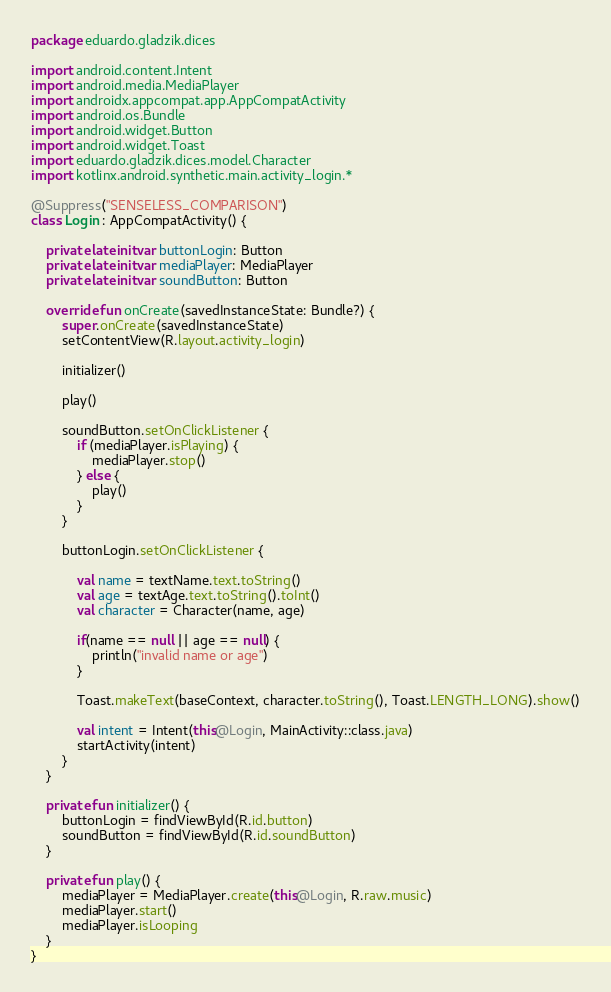Convert code to text. <code><loc_0><loc_0><loc_500><loc_500><_Kotlin_>package eduardo.gladzik.dices

import android.content.Intent
import android.media.MediaPlayer
import androidx.appcompat.app.AppCompatActivity
import android.os.Bundle
import android.widget.Button
import android.widget.Toast
import eduardo.gladzik.dices.model.Character
import kotlinx.android.synthetic.main.activity_login.*

@Suppress("SENSELESS_COMPARISON")
class Login : AppCompatActivity() {

    private lateinit var buttonLogin: Button
    private lateinit var mediaPlayer: MediaPlayer
    private lateinit var soundButton: Button

    override fun onCreate(savedInstanceState: Bundle?) {
        super.onCreate(savedInstanceState)
        setContentView(R.layout.activity_login)

        initializer()

        play()

        soundButton.setOnClickListener {
            if (mediaPlayer.isPlaying) {
                mediaPlayer.stop()
            } else {
                play()
            }
        }

        buttonLogin.setOnClickListener {

            val name = textName.text.toString()
            val age = textAge.text.toString().toInt()
            val character = Character(name, age)

            if(name == null || age == null) {
                println("invalid name or age")
            }

            Toast.makeText(baseContext, character.toString(), Toast.LENGTH_LONG).show()

            val intent = Intent(this@Login, MainActivity::class.java)
            startActivity(intent)
        }
    }

    private fun initializer() {
        buttonLogin = findViewById(R.id.button)
        soundButton = findViewById(R.id.soundButton)
    }

    private fun play() {
        mediaPlayer = MediaPlayer.create(this@Login, R.raw.music)
        mediaPlayer.start()
        mediaPlayer.isLooping
    }
}</code> 